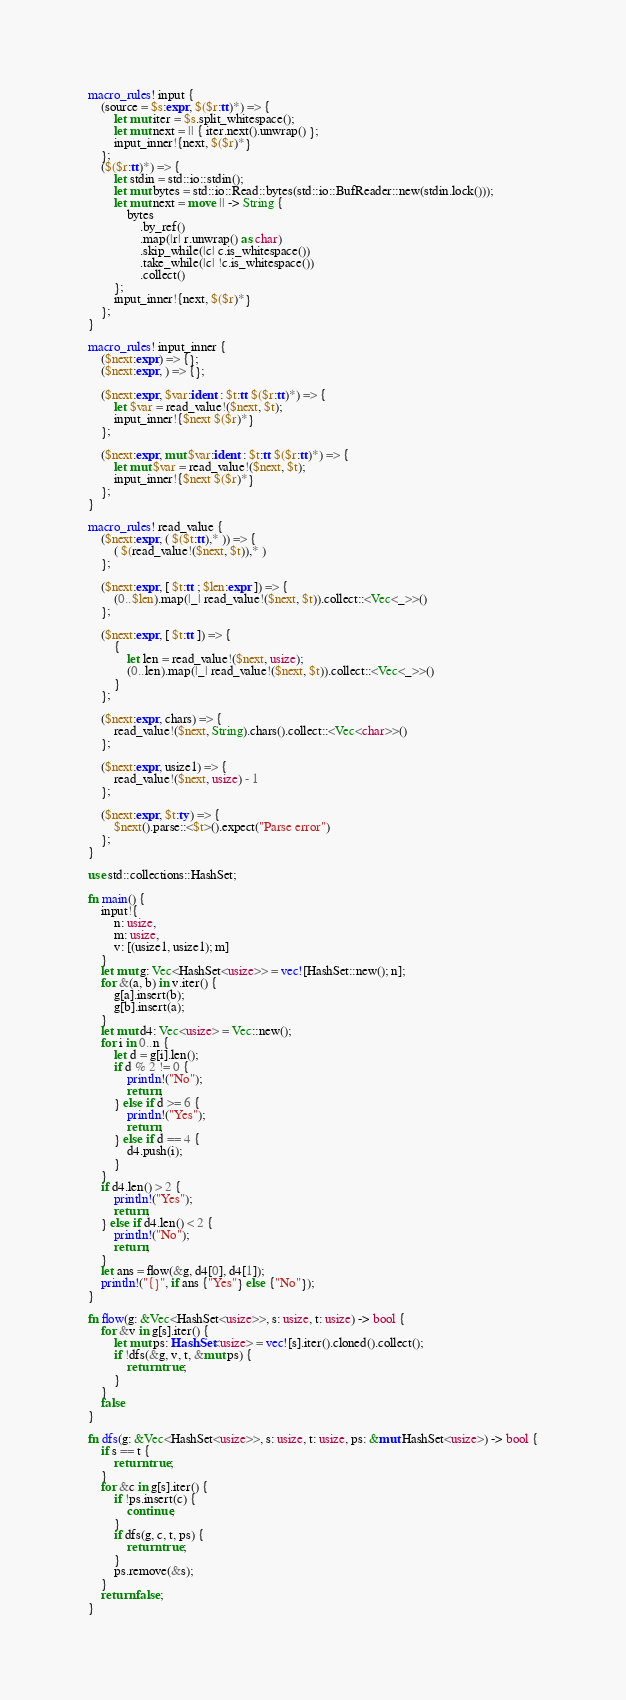<code> <loc_0><loc_0><loc_500><loc_500><_Rust_>macro_rules! input {
    (source = $s:expr, $($r:tt)*) => {
        let mut iter = $s.split_whitespace();
        let mut next = || { iter.next().unwrap() };
        input_inner!{next, $($r)*}
    };
    ($($r:tt)*) => {
        let stdin = std::io::stdin();
        let mut bytes = std::io::Read::bytes(std::io::BufReader::new(stdin.lock()));
        let mut next = move || -> String {
            bytes
                .by_ref()
                .map(|r| r.unwrap() as char)
                .skip_while(|c| c.is_whitespace())
                .take_while(|c| !c.is_whitespace())
                .collect()
        };
        input_inner!{next, $($r)*}
    };
}

macro_rules! input_inner {
    ($next:expr) => {};
    ($next:expr, ) => {};

    ($next:expr, $var:ident : $t:tt $($r:tt)*) => {
        let $var = read_value!($next, $t);
        input_inner!{$next $($r)*}
    };

    ($next:expr, mut $var:ident : $t:tt $($r:tt)*) => {
        let mut $var = read_value!($next, $t);
        input_inner!{$next $($r)*}
    };
}

macro_rules! read_value {
    ($next:expr, ( $($t:tt),* )) => {
        ( $(read_value!($next, $t)),* )
    };

    ($next:expr, [ $t:tt ; $len:expr ]) => {
        (0..$len).map(|_| read_value!($next, $t)).collect::<Vec<_>>()
    };

    ($next:expr, [ $t:tt ]) => {
        {
            let len = read_value!($next, usize);
            (0..len).map(|_| read_value!($next, $t)).collect::<Vec<_>>()
        }
    };

    ($next:expr, chars) => {
        read_value!($next, String).chars().collect::<Vec<char>>()
    };

    ($next:expr, usize1) => {
        read_value!($next, usize) - 1
    };

    ($next:expr, $t:ty) => {
        $next().parse::<$t>().expect("Parse error")
    };
}

use std::collections::HashSet;

fn main() {
    input!{
        n: usize,
        m: usize,
        v: [(usize1, usize1); m]
    }
    let mut g: Vec<HashSet<usize>> = vec![HashSet::new(); n];
    for &(a, b) in v.iter() {
        g[a].insert(b);
        g[b].insert(a);
    }
    let mut d4: Vec<usize> = Vec::new();
    for i in 0..n {
        let d = g[i].len();
        if d % 2 != 0 {
            println!("No");
            return;
        } else if d >= 6 {
            println!("Yes");
            return;
        } else if d == 4 {
            d4.push(i);
        }
    }
    if d4.len() > 2 {
        println!("Yes");
        return;
    } else if d4.len() < 2 {
        println!("No");
        return;
    }
    let ans = flow(&g, d4[0], d4[1]);
    println!("{}", if ans {"Yes"} else {"No"});
}

fn flow(g: &Vec<HashSet<usize>>, s: usize, t: usize) -> bool {
    for &v in g[s].iter() {
        let mut ps: HashSet<usize> = vec![s].iter().cloned().collect();
        if !dfs(&g, v, t, &mut ps) {
            return true;
        }
    }
    false
}

fn dfs(g: &Vec<HashSet<usize>>, s: usize, t: usize, ps: &mut HashSet<usize>) -> bool {
    if s == t {
        return true;
    }
    for &c in g[s].iter() {
        if !ps.insert(c) {
            continue;
        }
        if dfs(g, c, t, ps) {
            return true;
        }
        ps.remove(&s);
    }
    return false;
}
</code> 